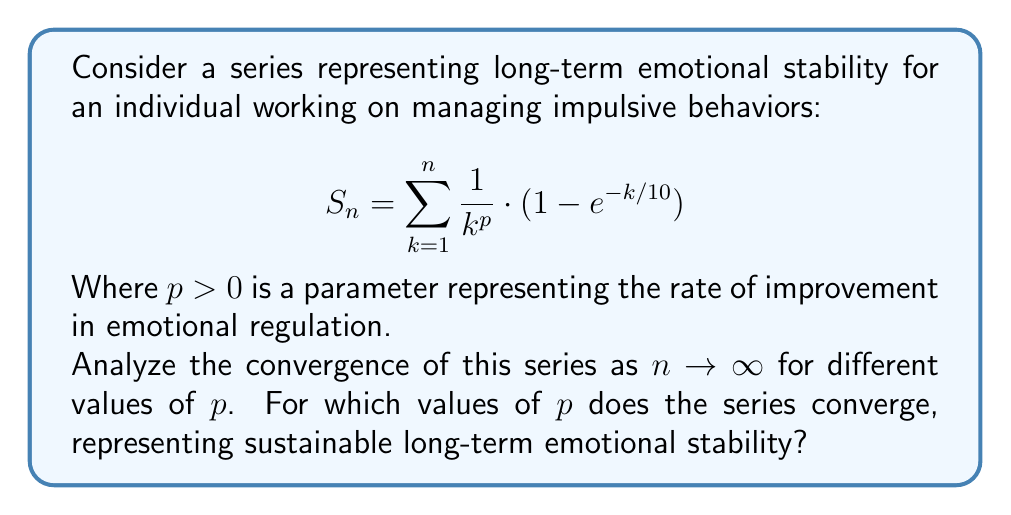Could you help me with this problem? To analyze the convergence of this series, we'll use the limit comparison test with a p-series.

Step 1: Consider the general term of the series:
$$a_k = \frac{1}{k^p} \cdot (1 - e^{-k/10})$$

Step 2: Compare this with the general term of a p-series:
$$b_k = \frac{1}{k^p}$$

Step 3: Calculate the limit of their ratio as $k \to \infty$:
$$\lim_{k \to \infty} \frac{a_k}{b_k} = \lim_{k \to \infty} (1 - e^{-k/10}) = 1$$

Step 4: By the limit comparison test, our series converges if and only if the p-series $\sum_{k=1}^{\infty} \frac{1}{k^p}$ converges.

Step 5: Recall that a p-series converges if and only if $p > 1$.

Therefore, our series converges when $p > 1$, representing sustainable long-term emotional stability. For $p \leq 1$, the series diverges, indicating potential challenges in achieving long-term stability.
Answer: The series converges for $p > 1$. 